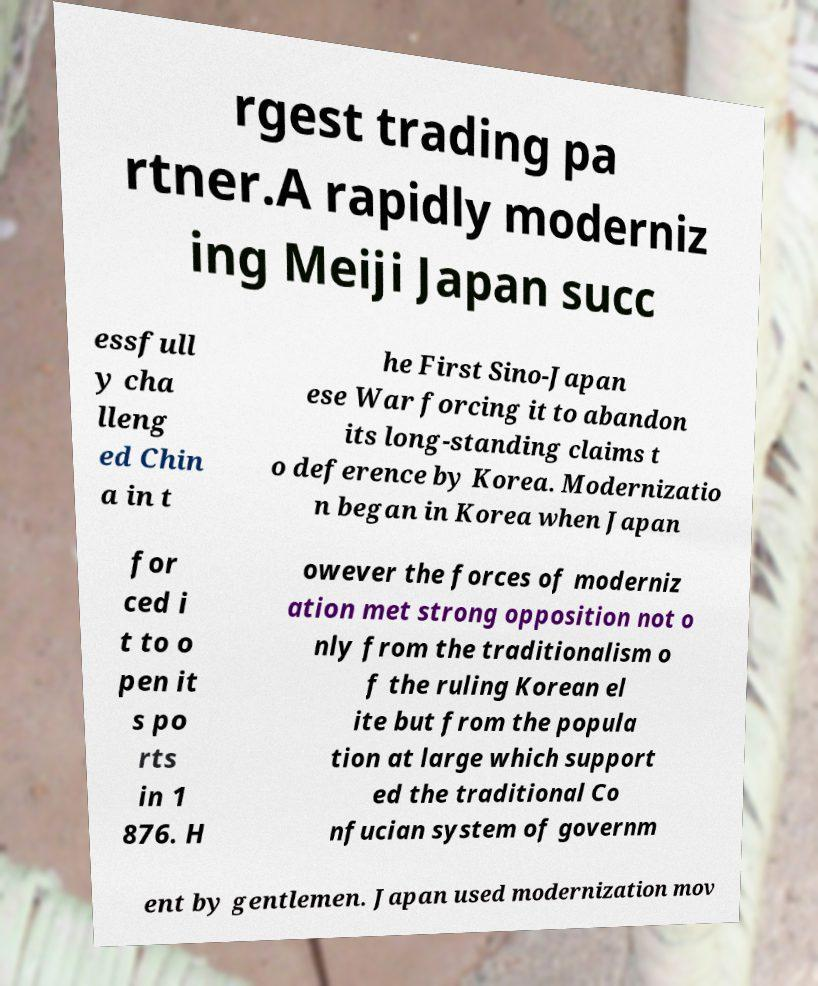What messages or text are displayed in this image? I need them in a readable, typed format. rgest trading pa rtner.A rapidly moderniz ing Meiji Japan succ essfull y cha lleng ed Chin a in t he First Sino-Japan ese War forcing it to abandon its long-standing claims t o deference by Korea. Modernizatio n began in Korea when Japan for ced i t to o pen it s po rts in 1 876. H owever the forces of moderniz ation met strong opposition not o nly from the traditionalism o f the ruling Korean el ite but from the popula tion at large which support ed the traditional Co nfucian system of governm ent by gentlemen. Japan used modernization mov 